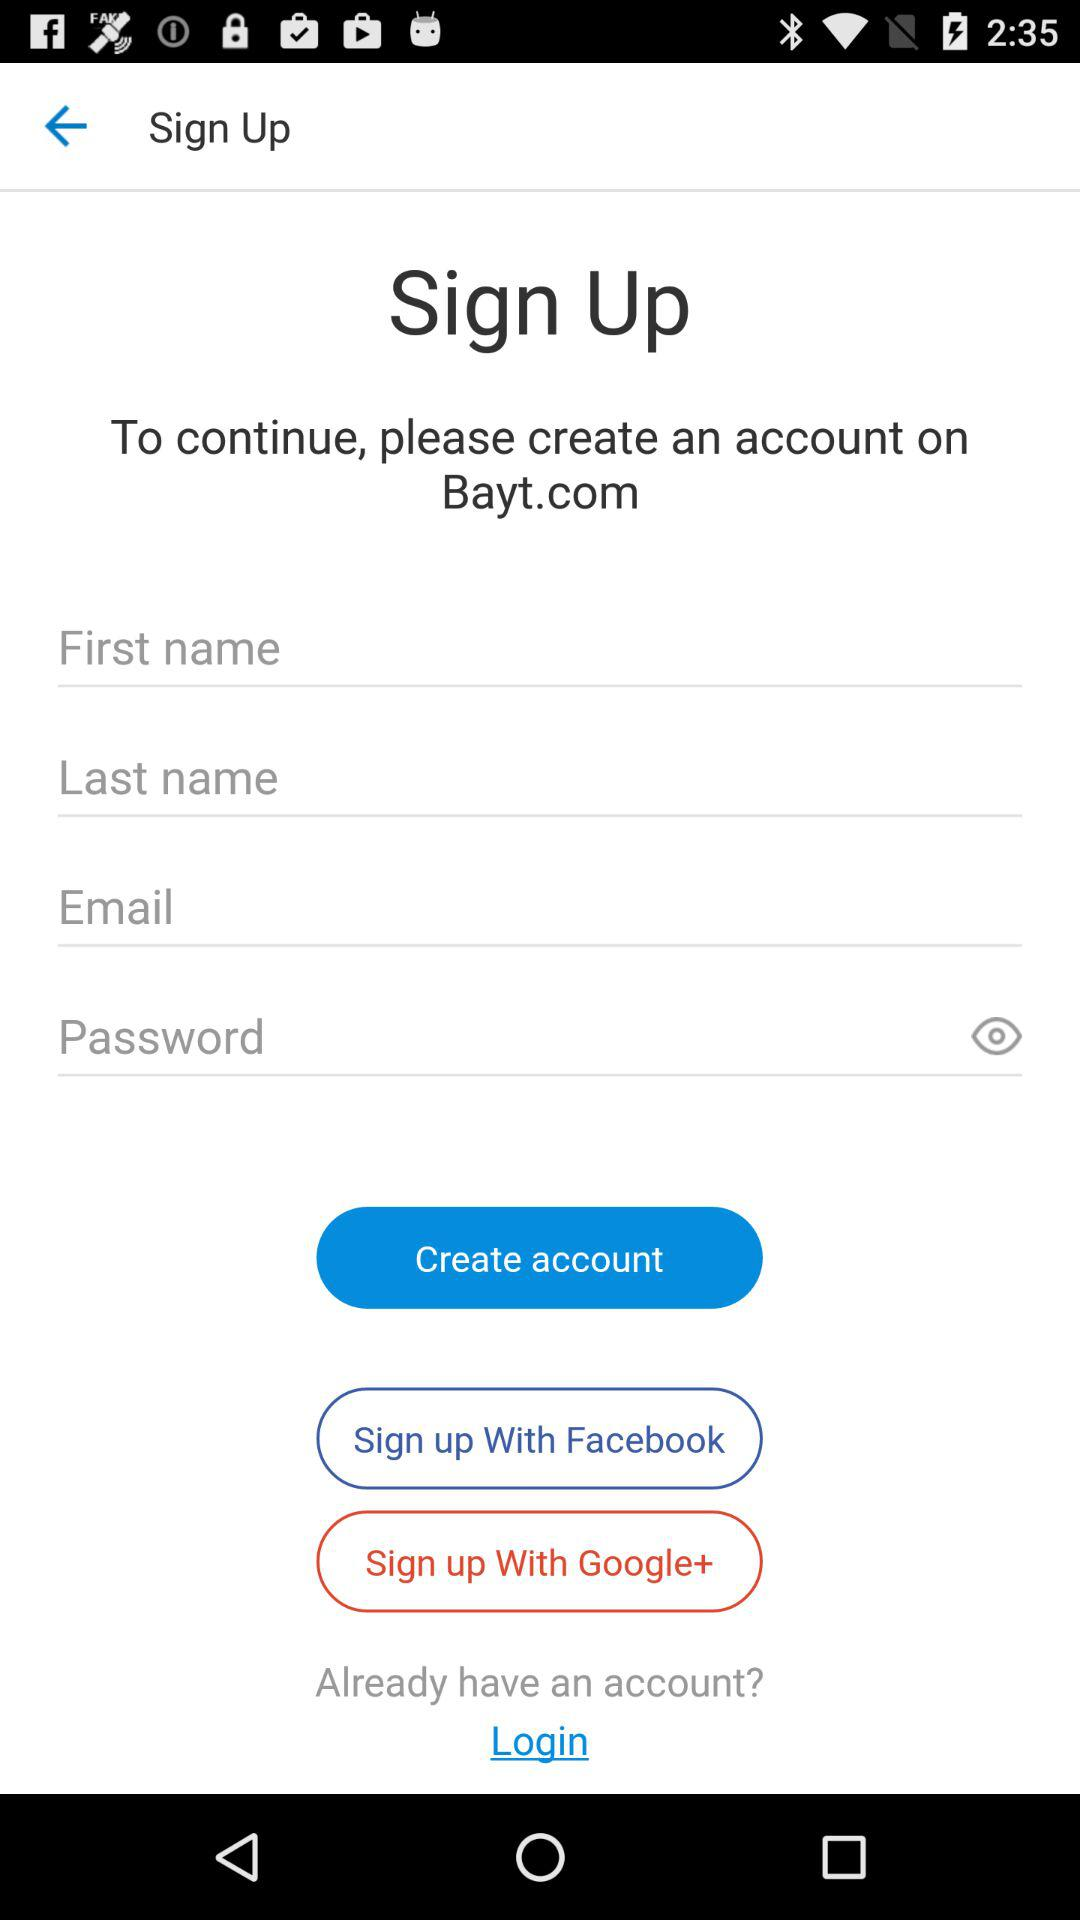What are the different options available for signing up? The different options that are available for signing up are "Facebook" and "Google+". 